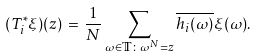Convert formula to latex. <formula><loc_0><loc_0><loc_500><loc_500>( T _ { i } ^ { \ast } \xi ) ( z ) \, = \, \frac { 1 } { N } \sum _ { \omega \in \mathbb { T } \colon \omega ^ { N } = z } \overline { h _ { i } ( \omega ) } \xi ( \omega ) .</formula> 